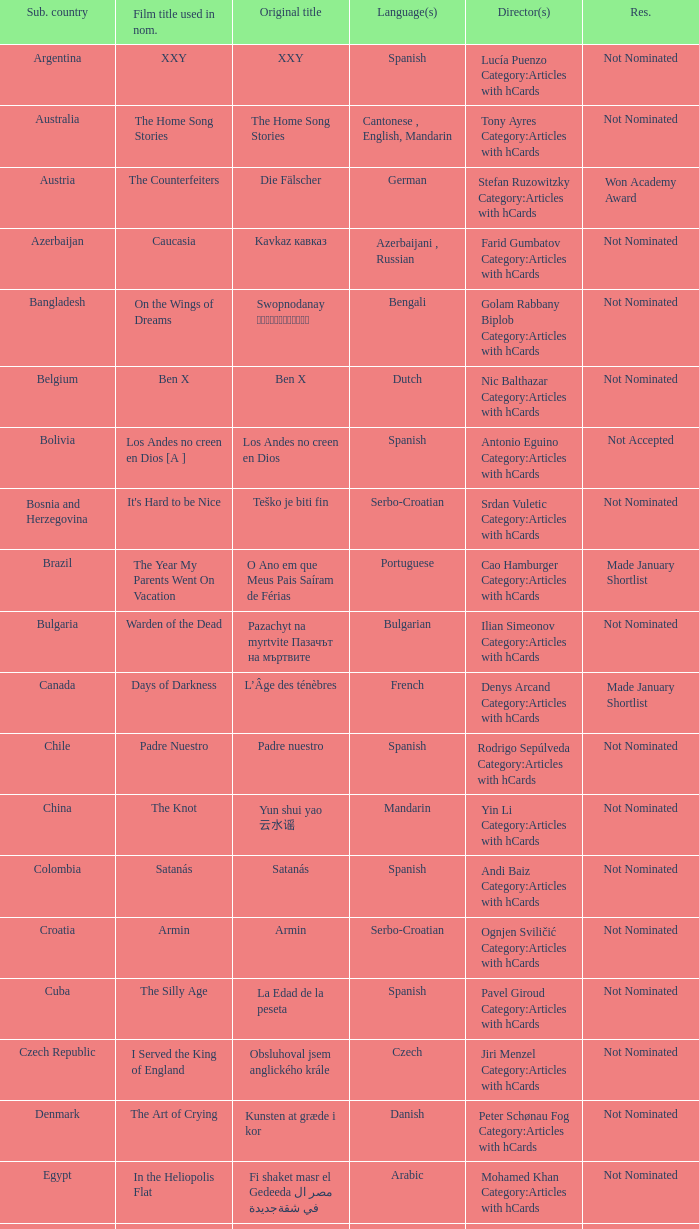What country submitted the movie the orphanage? Spain. 